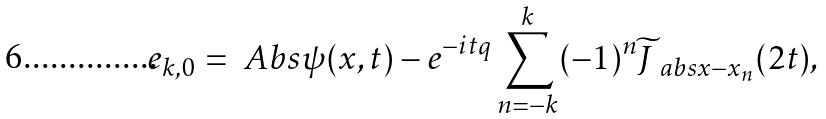<formula> <loc_0><loc_0><loc_500><loc_500>e _ { k , 0 } = \ A b s { \psi ( x , t ) - e ^ { - i t q } \sum _ { n = - k } ^ { k } ( - 1 ) ^ { n } \widetilde { J } _ { \ a b s { x - x _ { n } } } ( 2 t ) } ,</formula> 